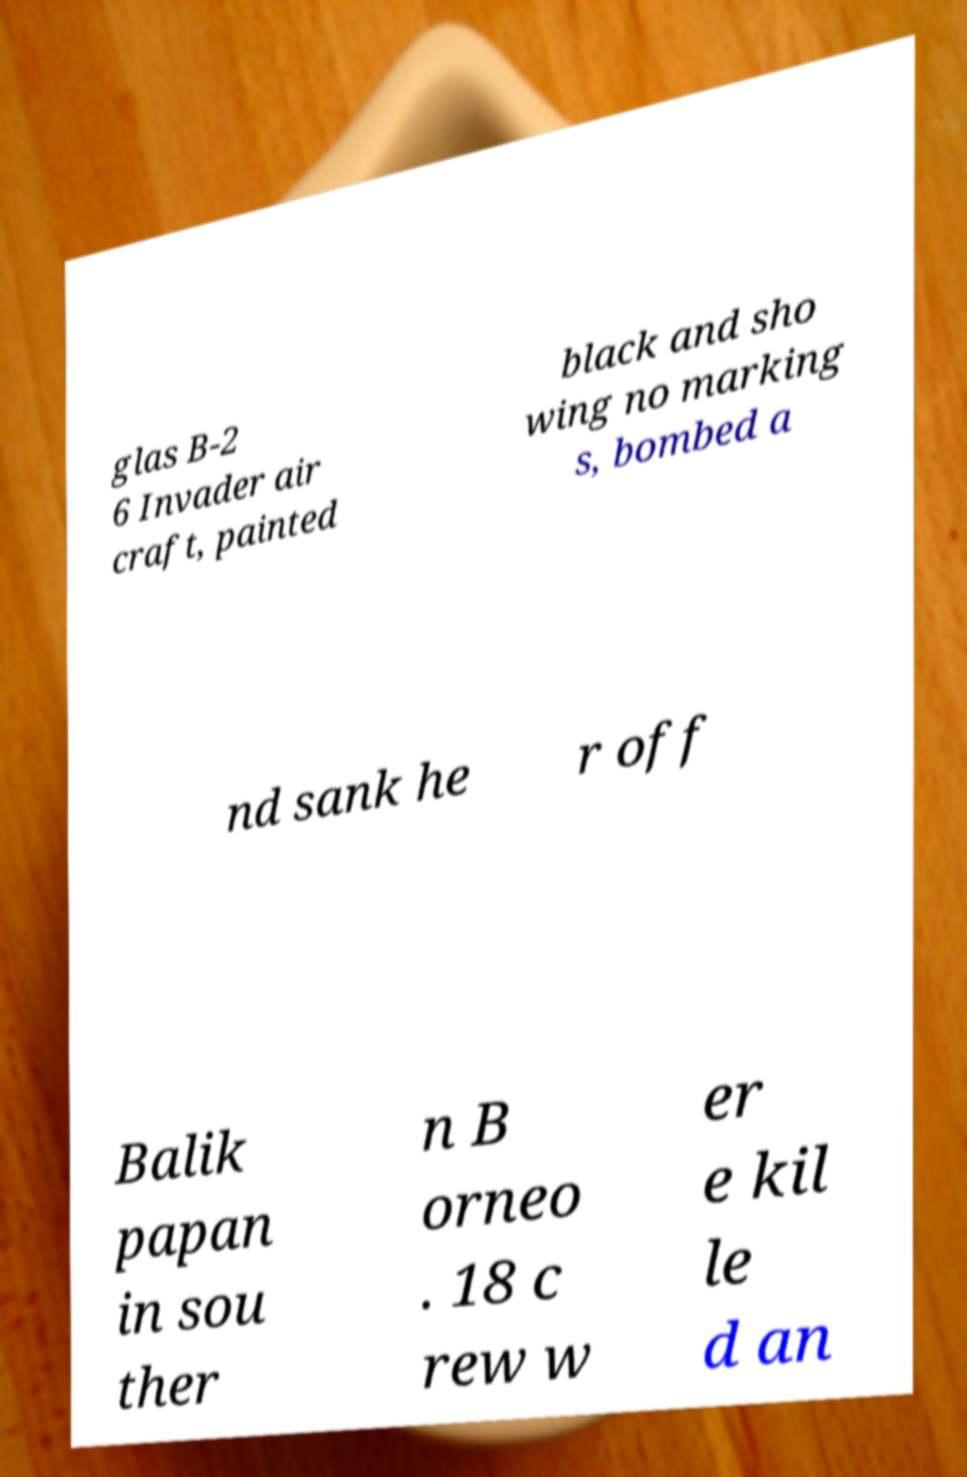Could you assist in decoding the text presented in this image and type it out clearly? glas B-2 6 Invader air craft, painted black and sho wing no marking s, bombed a nd sank he r off Balik papan in sou ther n B orneo . 18 c rew w er e kil le d an 